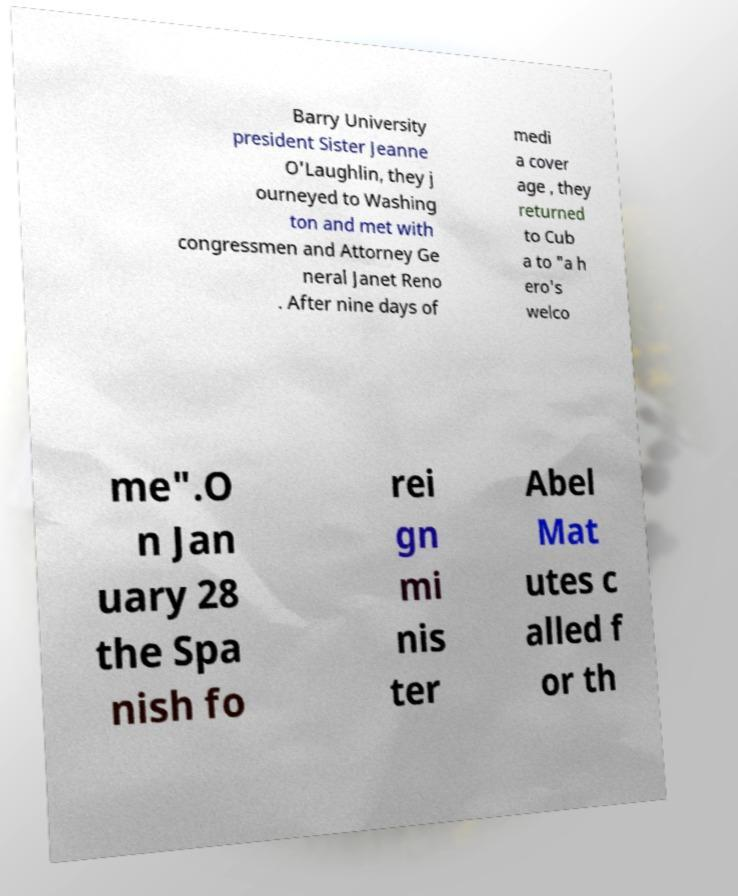Please read and relay the text visible in this image. What does it say? Barry University president Sister Jeanne O'Laughlin, they j ourneyed to Washing ton and met with congressmen and Attorney Ge neral Janet Reno . After nine days of medi a cover age , they returned to Cub a to "a h ero's welco me".O n Jan uary 28 the Spa nish fo rei gn mi nis ter Abel Mat utes c alled f or th 